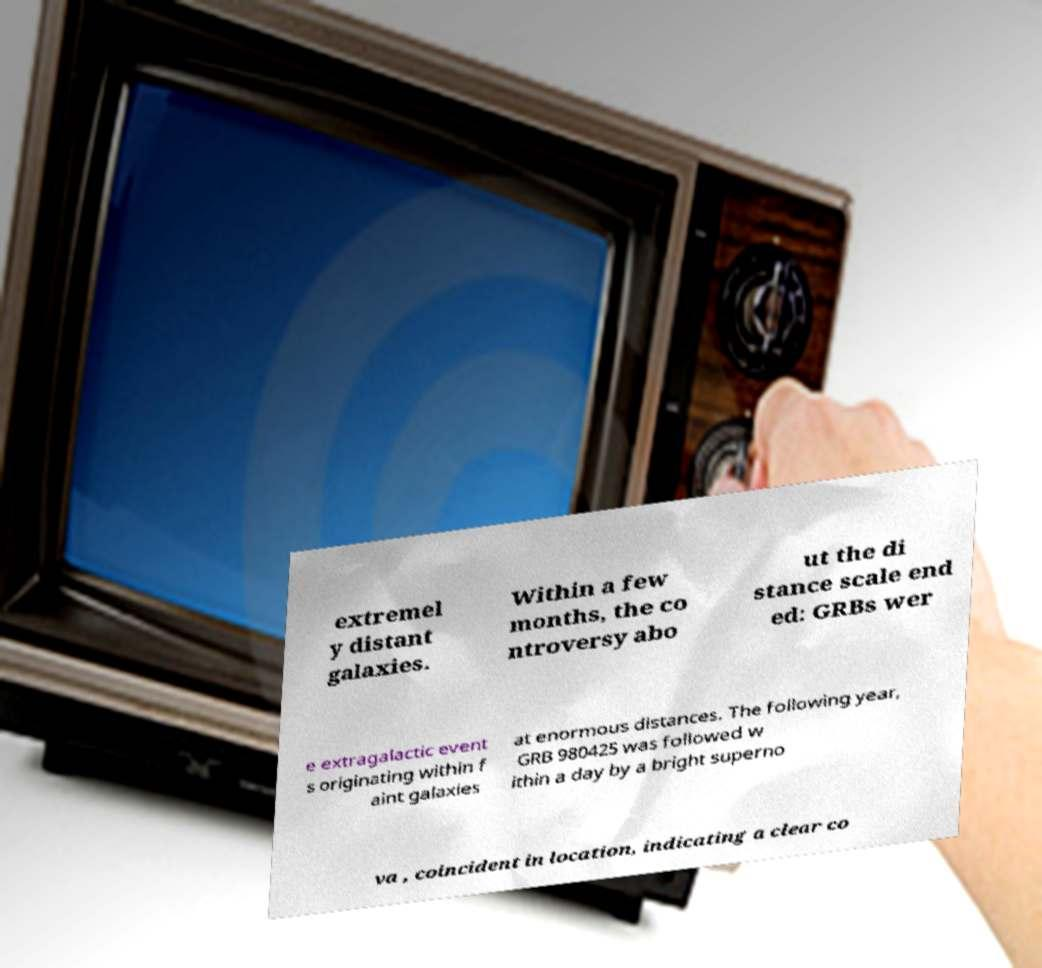Can you read and provide the text displayed in the image?This photo seems to have some interesting text. Can you extract and type it out for me? extremel y distant galaxies. Within a few months, the co ntroversy abo ut the di stance scale end ed: GRBs wer e extragalactic event s originating within f aint galaxies at enormous distances. The following year, GRB 980425 was followed w ithin a day by a bright superno va , coincident in location, indicating a clear co 